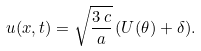Convert formula to latex. <formula><loc_0><loc_0><loc_500><loc_500>u ( x , t ) = \sqrt { \frac { 3 \, c } { a } } \, ( U ( \theta ) + \delta ) .</formula> 